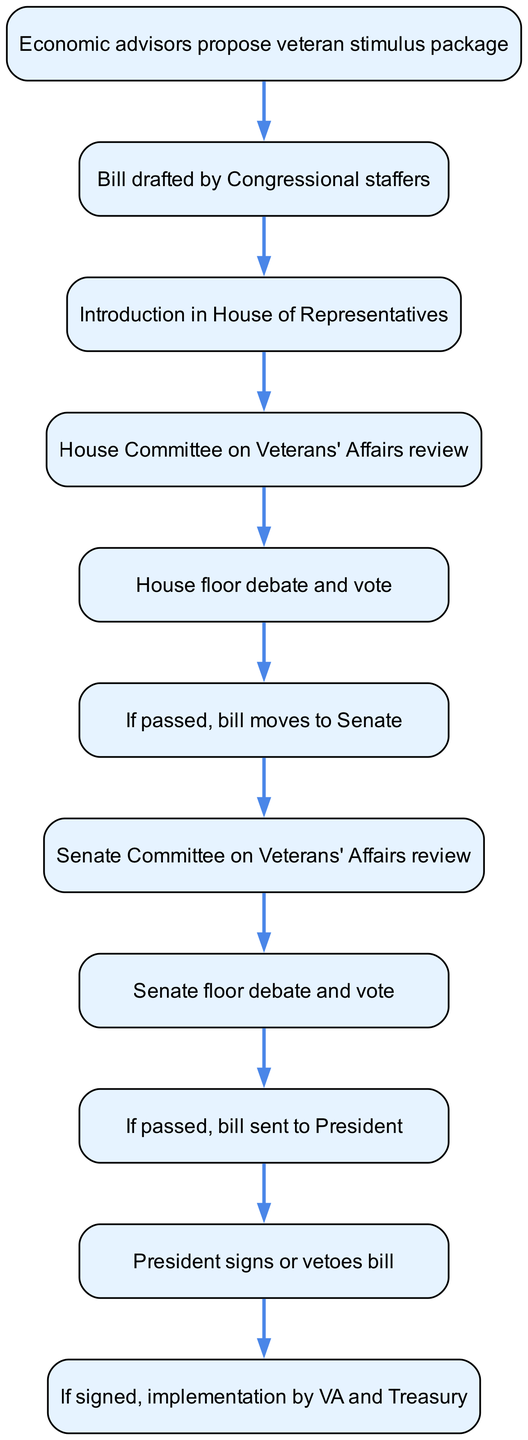What is the first step in the legislative process for approving veteran-focused economic stimulus packages? The first step is the proposal made by economic advisors for a veteran stimulus package. This is indicated as the starting point in the flow chart.
Answer: Economic advisors propose veteran stimulus package How many main steps are there in the legislative process shown in the diagram? By counting the nodes in the flow chart (from the proposal to the implementation), there are a total of 11 steps in the process.
Answer: 11 What happens after the House floor debate and vote? Following the House floor debate and vote, if the bill passes, it moves to the Senate for further consideration. The diagram clearly shows this sequential step.
Answer: If passed, bill moves to Senate What is the final outcome if the President signs the bill? If the President signs the bill, the final outcome is that the implementation is carried out by the VA and Treasury. This is the last step represented in the diagram.
Answer: Implementation by VA and Treasury Which committee reviews the bill before it is introduced to the Senate? The Senate Committee on Veterans' Affairs reviews the bill prior to it being introduced on the Senate floor. This relationship is depicted in the flow of the diagram.
Answer: Senate Committee on Veterans' Affairs review Does the process include a step where the President can veto the bill? Yes, there is a step where the President can either sign or veto the bill, indicating that a veto is a possible outcome of this process.
Answer: Yes What step occurs immediately after the House Committee on Veterans' Affairs review? The immediate next step after the House Committee on Veterans' Affairs review is the House floor debate and vote, as shown in the flow.
Answer: House floor debate and vote What does the diagram indicate happens if the Senate passes the bill? If the Senate passes the bill, it is sent to the President for final action, as detailed in the flow chart.
Answer: Bill sent to President What is the main purpose of the legislative process depicted in the diagram? The main purpose is to approve a veteran-focused economic stimulus package, which is the core theme of the flow chart.
Answer: Approve veteran-focused economic stimulus package 